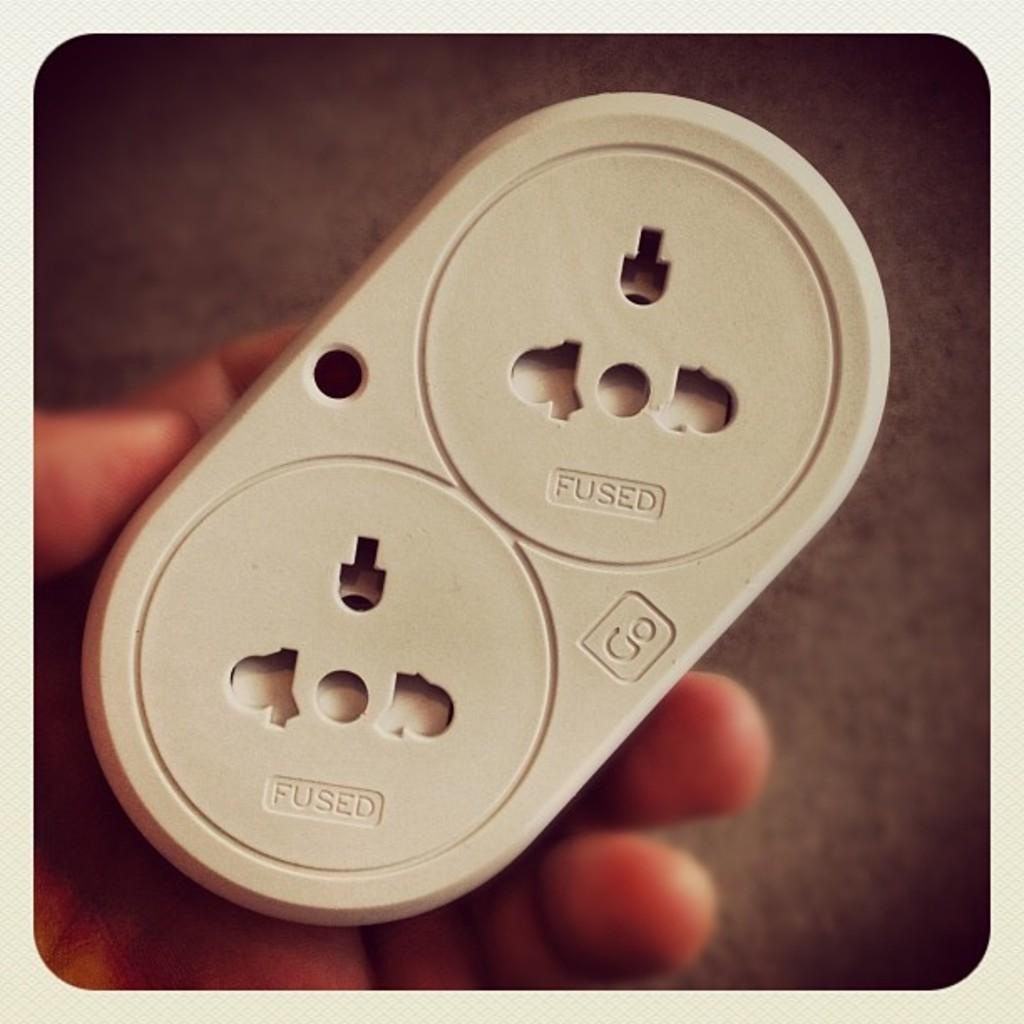What type of object is visible in the image that is used for providing electricity? There is an electric socket in the image. What part of the human body can be seen in the image? There is a human hand in the image. How does the electric socket contribute to the health of the person in the image? The electric socket is not directly related to the health of the person in the image; it is an object used for providing electricity. What type of weather condition is depicted in the image, such as an earthquake or rain? There is no indication of any weather conditions, such as an earthquake or rain, in the image. 